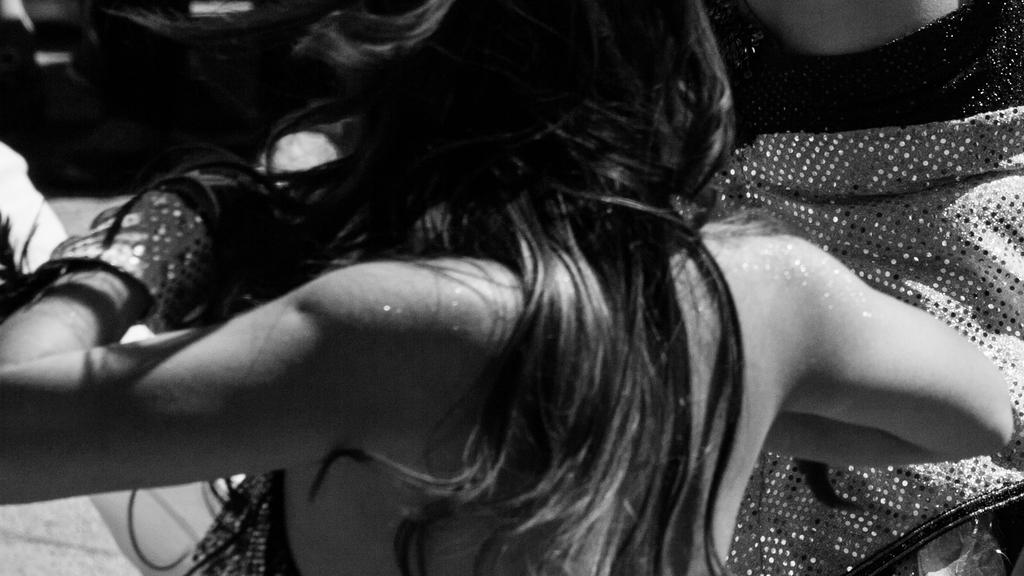Who is the main subject in the image? There is a lady in the center of the image. What else can be seen in the image besides the lady? There are clothes on the right side of the image. How does the lady react to the earthquake in the image? There is no earthquake present in the image, so the lady's reaction cannot be determined. 